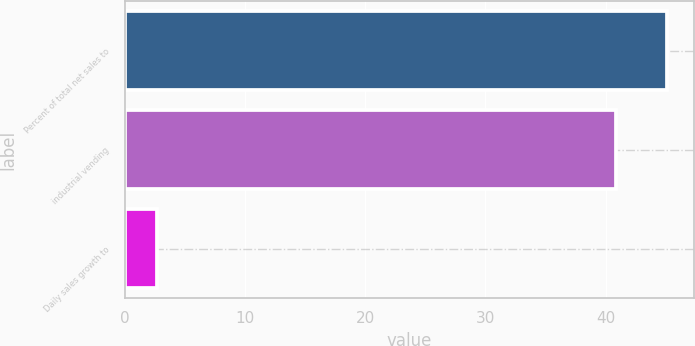Convert chart to OTSL. <chart><loc_0><loc_0><loc_500><loc_500><bar_chart><fcel>Percent of total net sales to<fcel>industrial vending<fcel>Daily sales growth to<nl><fcel>45.09<fcel>40.9<fcel>2.7<nl></chart> 